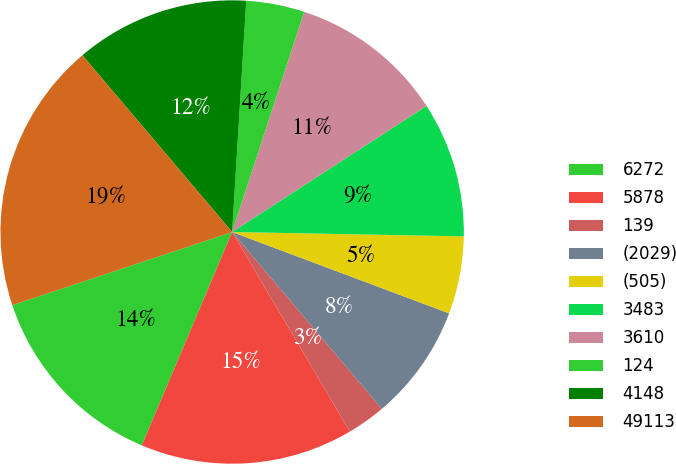<chart> <loc_0><loc_0><loc_500><loc_500><pie_chart><fcel>6272<fcel>5878<fcel>139<fcel>(2029)<fcel>(505)<fcel>3483<fcel>3610<fcel>124<fcel>4148<fcel>49113<nl><fcel>13.51%<fcel>14.86%<fcel>2.7%<fcel>8.11%<fcel>5.41%<fcel>9.46%<fcel>10.81%<fcel>4.06%<fcel>12.16%<fcel>18.92%<nl></chart> 